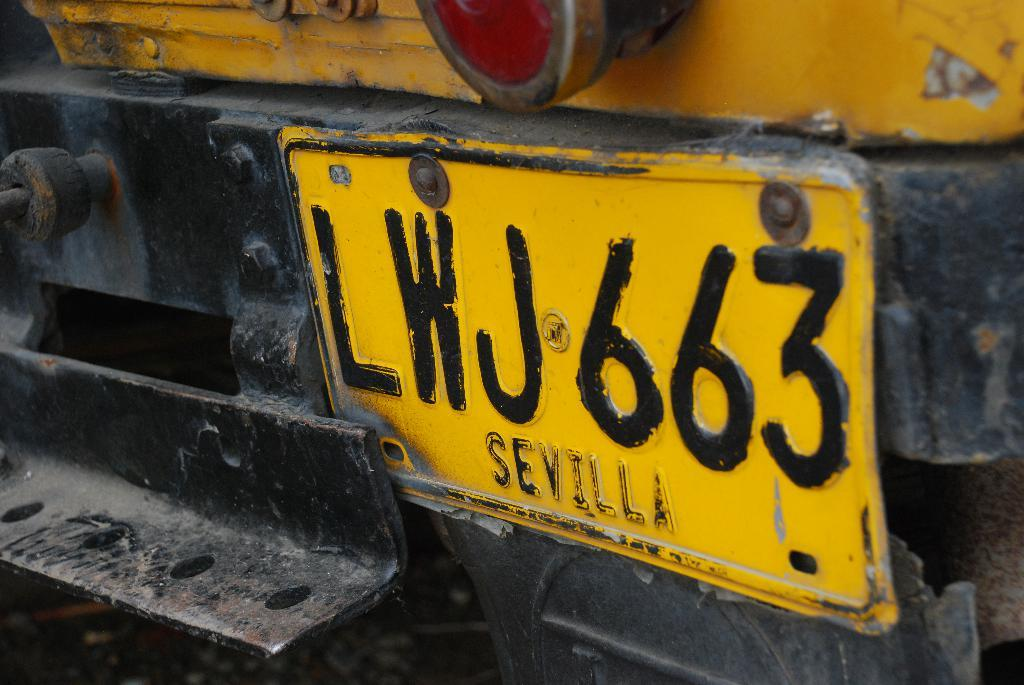What is the main subject of the picture? The main subject of the picture is a vehicle. Does the vehicle have any identifying features? Yes, the vehicle has a number plate with text on it. Can you describe the light on the vehicle? There is a light on the vehicle, but its specific characteristics are not mentioned in the facts. What type of wound can be seen on the vehicle's sister in the image? There is no mention of a wound or a sister in the image, as the facts only describe the vehicle and its features. 